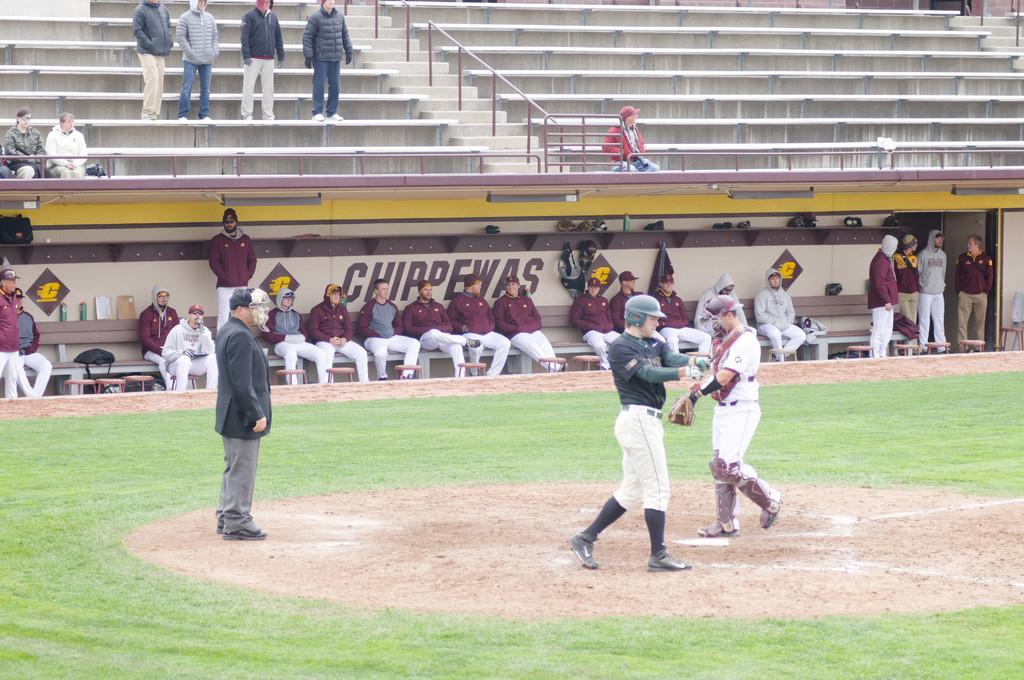<image>
Present a compact description of the photo's key features. The Chippewas' dugout is full of people at this game. 